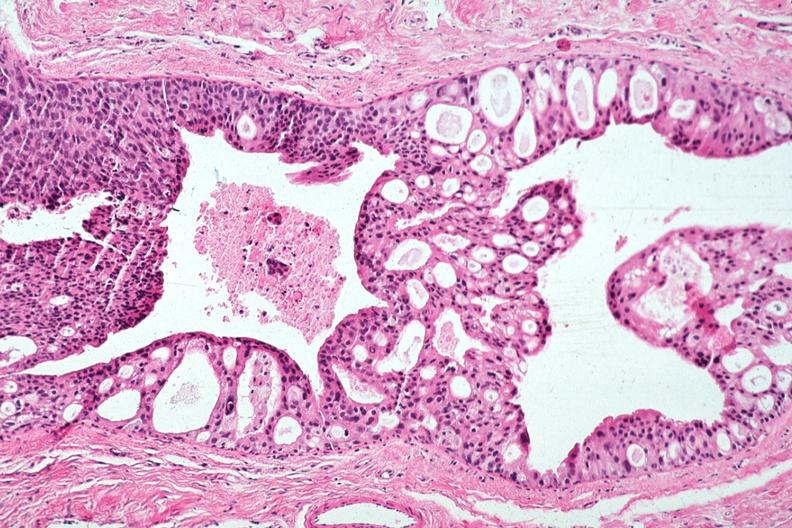what is present?
Answer the question using a single word or phrase. Breast 